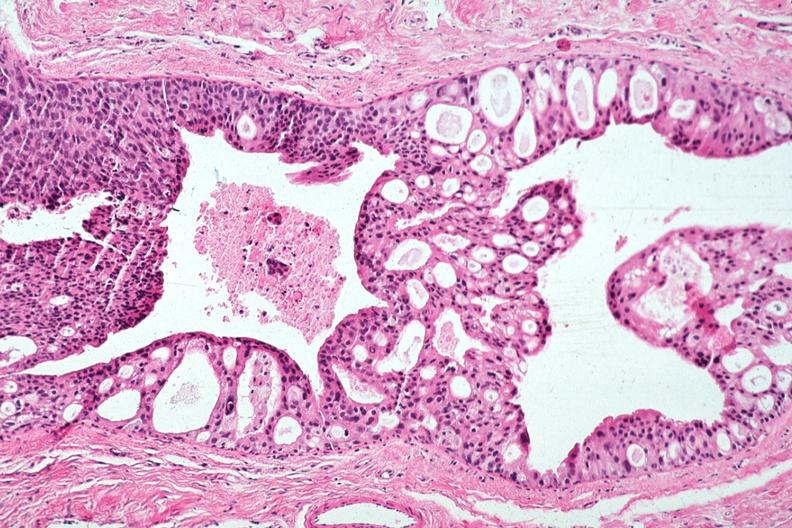what is present?
Answer the question using a single word or phrase. Breast 